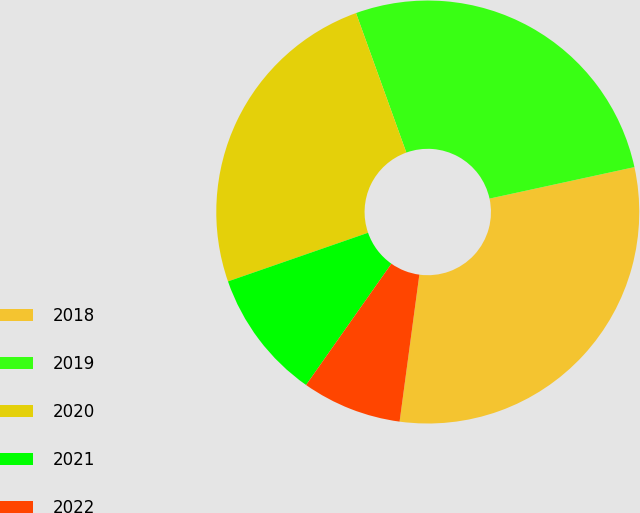<chart> <loc_0><loc_0><loc_500><loc_500><pie_chart><fcel>2018<fcel>2019<fcel>2020<fcel>2021<fcel>2022<nl><fcel>30.53%<fcel>27.1%<fcel>24.81%<fcel>9.92%<fcel>7.63%<nl></chart> 